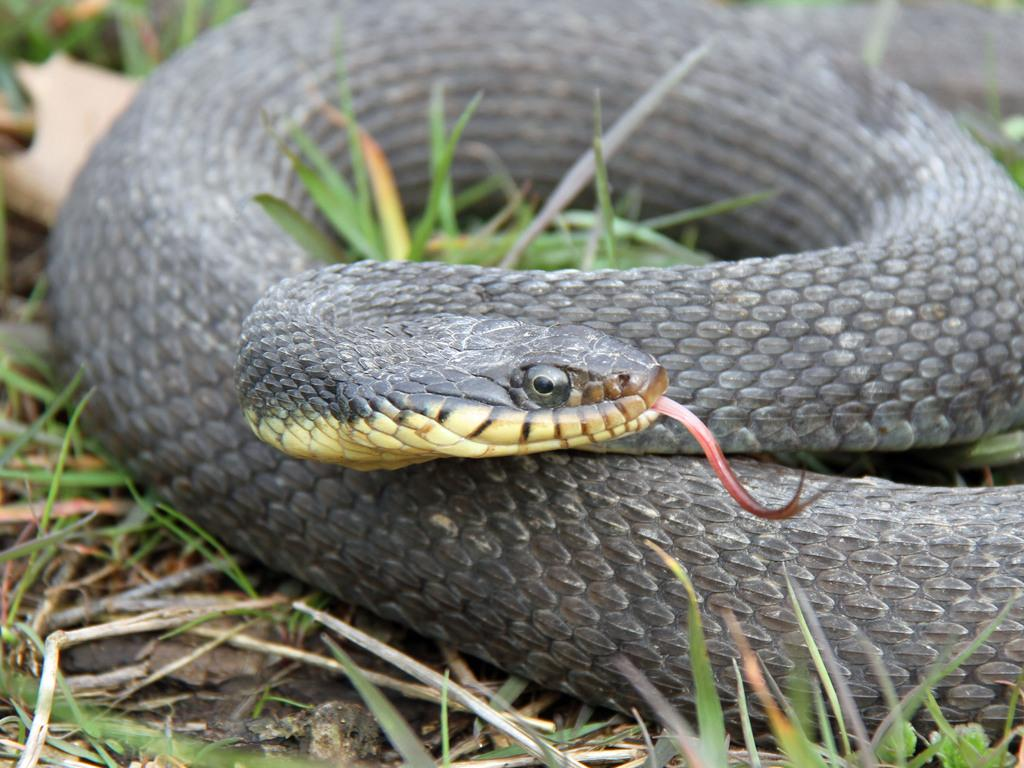What animal is present in the picture? There is a snake in the picture. What is the color of the snake? The snake is black in color. Where is the snake located? The snake is on the grass. What is the purpose of the writer in the image? There is no writer present in the image, as it features a snake on the grass. 